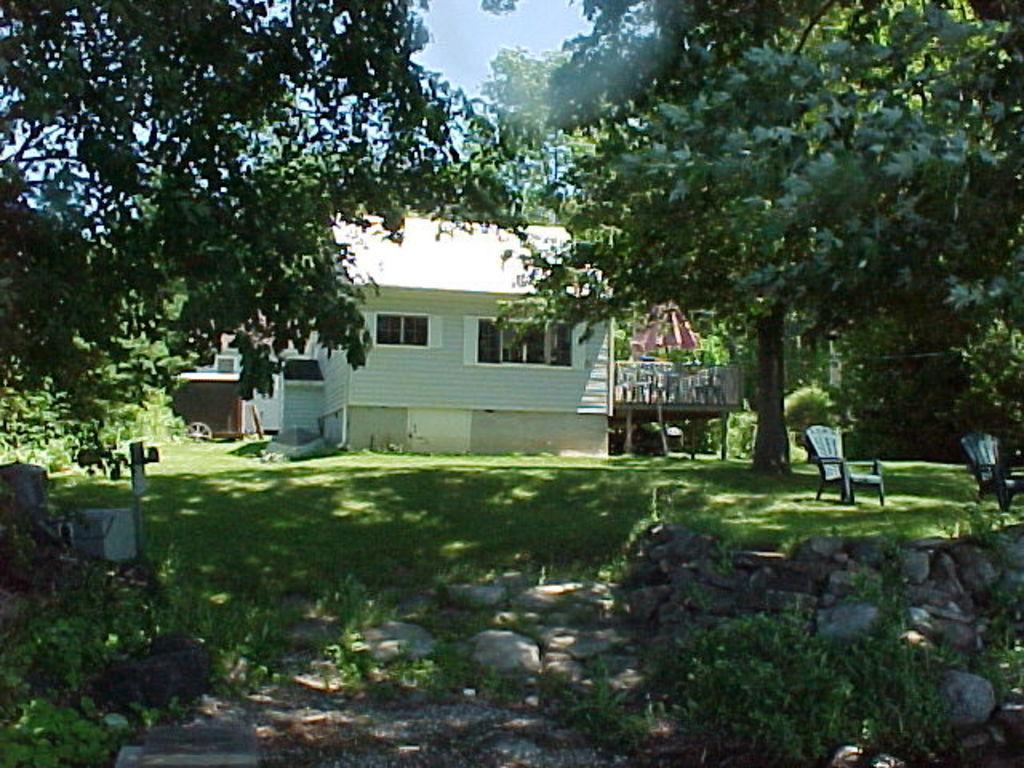Describe this image in one or two sentences. In the picture we can see picture we can see the grass surface, trees, chairs, house and the part of the sky. 